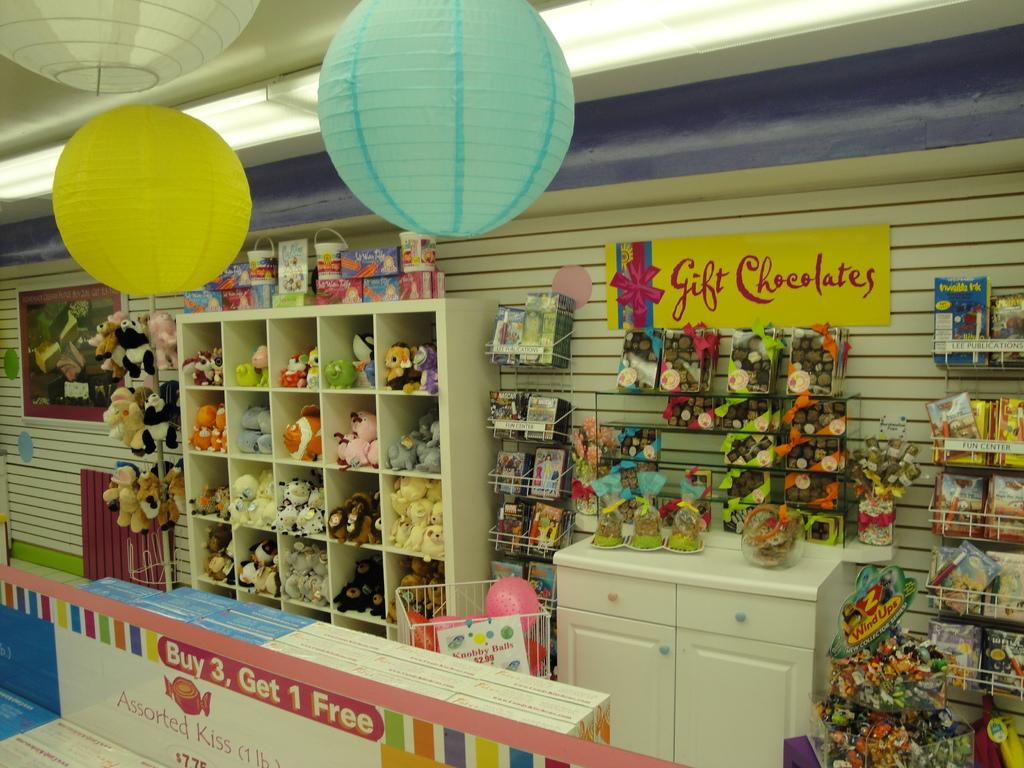What does it say on the yellow sign?
Ensure brevity in your answer.  Gift chocolates. What do you get if you buy 3?
Offer a terse response. 1 free. 